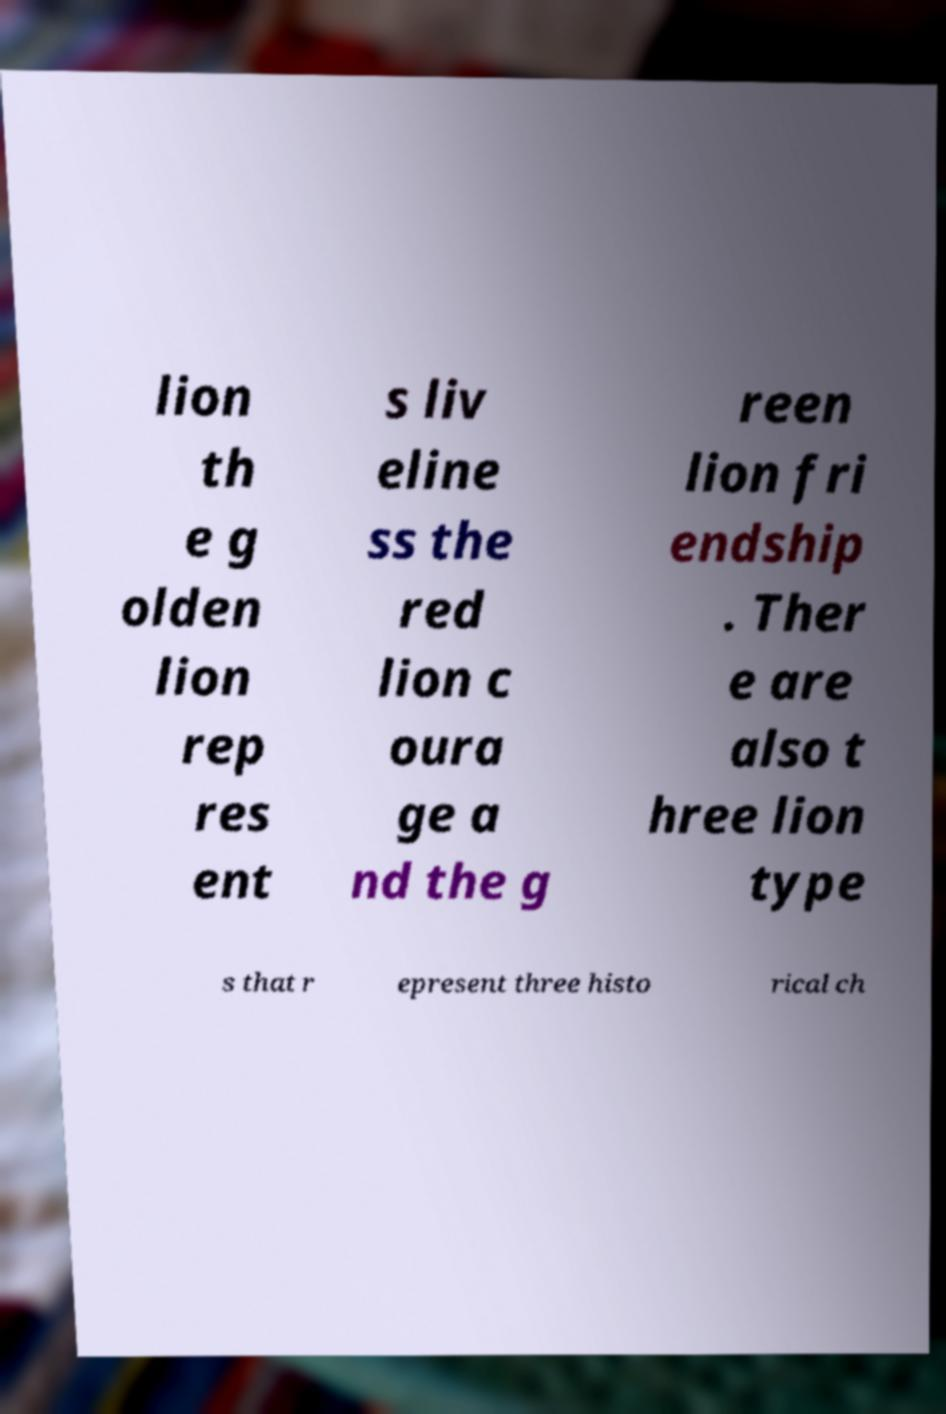What messages or text are displayed in this image? I need them in a readable, typed format. lion th e g olden lion rep res ent s liv eline ss the red lion c oura ge a nd the g reen lion fri endship . Ther e are also t hree lion type s that r epresent three histo rical ch 